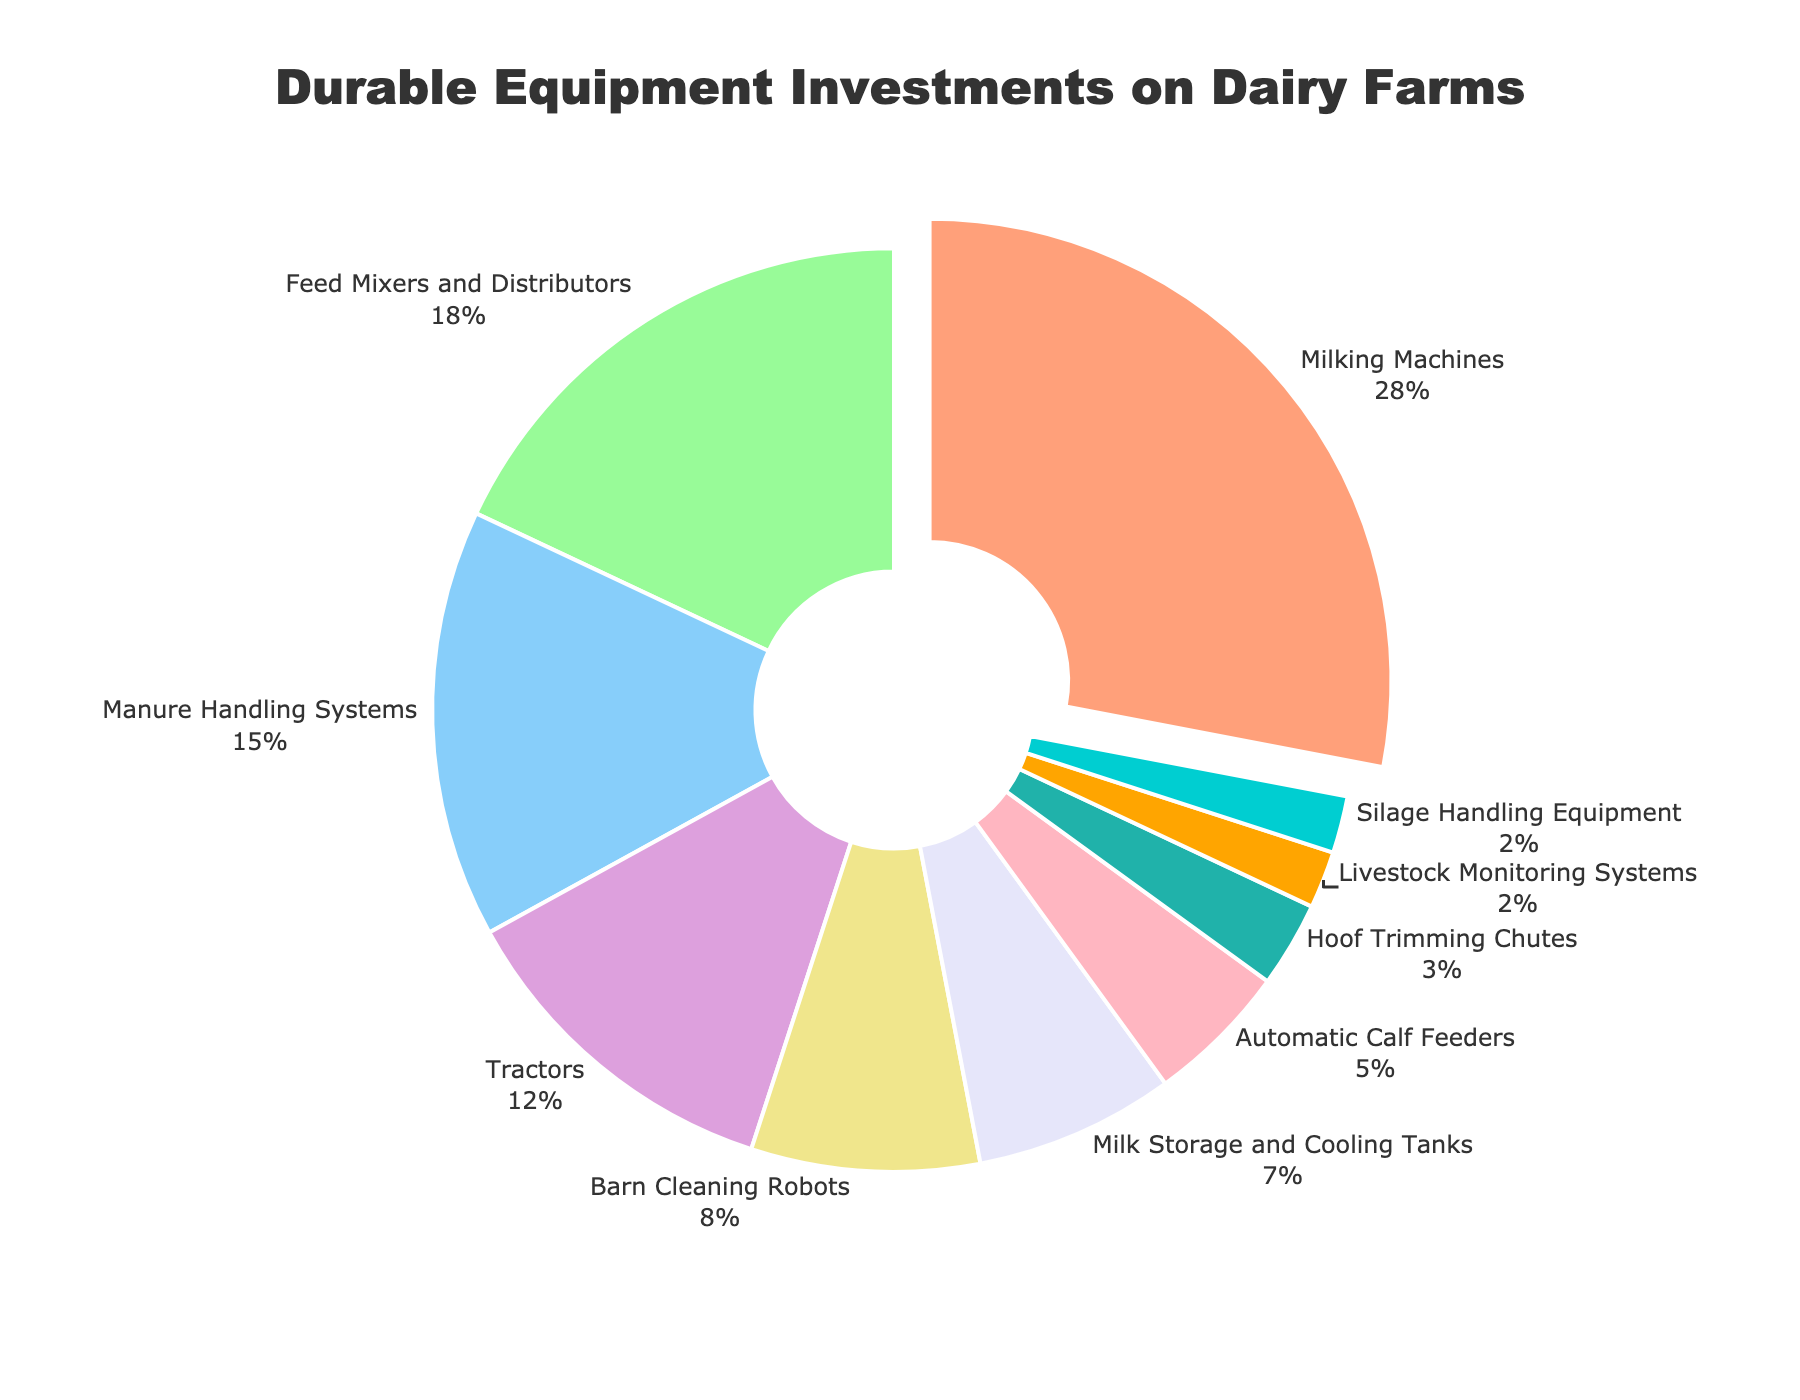Which type of equipment has the largest investment percentage? The figure shows different types of equipment with their respective percentages. Milking Machines are highlighted as having the highest percentage at 28%.
Answer: Milking Machines How much more is invested in Feed Mixers and Distributors compared to Silage Handling Equipment? Feed Mixers and Distributors have 18%, and Silage Handling Equipment has 2%. Subtracting these values gives 18% - 2% = 16%.
Answer: 16% What percentage is invested in Tractors? The figure lists the percentage for each equipment type. Tractors have a 12% investment.
Answer: 12% Compare the investment in Automatic Calf Feeders and Hoof Trimming Chutes. Which is higher and by how much? Automatic Calf Feeders have a 5% investment, while Hoof Trimming Chutes have 3%. Subtracting these values gives 5% - 3% = 2%.
Answer: Automatic Calf Feeders, 2% Which color represents the Milk Storage and Cooling Tanks investment? The pie chart uses colors to represent different investments. Milk Storage and Cooling Tanks are in light yellow.
Answer: Light yellow What is the combined investment percentage for Barn Cleaning Robots and Milk Storage and Cooling Tanks? Barn Cleaning Robots have 8%, and Milk Storage and Cooling Tanks have 7%. Adding these values gives 8% + 7% = 15%.
Answer: 15% What is the median investment percentage for the equipment types listed? Ordering the percentages: 2%, 2%, 3%, 5%, 7%, 8%, 12%, 15%, 18%, 28%. The median is the middle value. For an even number of data points, the median is the average of the two middle values (7% and 8%). (7% + 8%) / 2 = 7.5%.
Answer: 7.5% Is the investment in Livestock Monitoring Systems higher, lower, or equal to that in Silage Handling Equipment? Both Livestock Monitoring Systems and Silage Handling Equipment have a 2% investment.
Answer: Equal How much is the total investment percentage for the three types of equipment with the lowest percentages? The three lowest percentages are Livestock Monitoring Systems (2%), Silage Handling Equipment (2%), and Hoof Trimming Chutes (3%). Adding these gives 2% + 2% + 3% = 7%.
Answer: 7% Which equipment type is represented with a green color in the chart? The pie chart uses colors to represent different investments. Green represents Feed Mixers and Distributors.
Answer: Feed Mixers and Distributors 